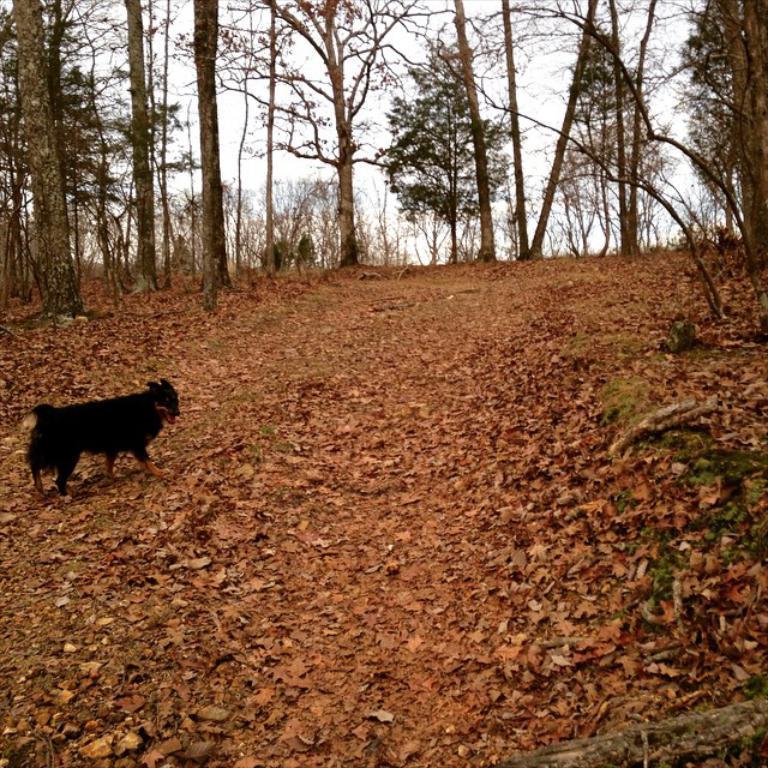In one or two sentences, can you explain what this image depicts? In this image we can see a dog. There are many trees in the image. There are many dry leaves on the ground. There is a sky in the image. 